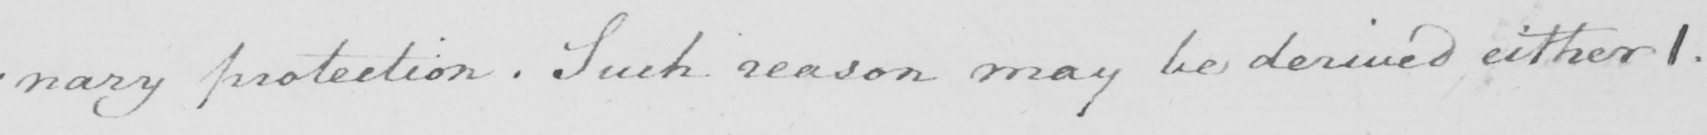Please provide the text content of this handwritten line. : nary protection . Such reason may be derived either 1 . 